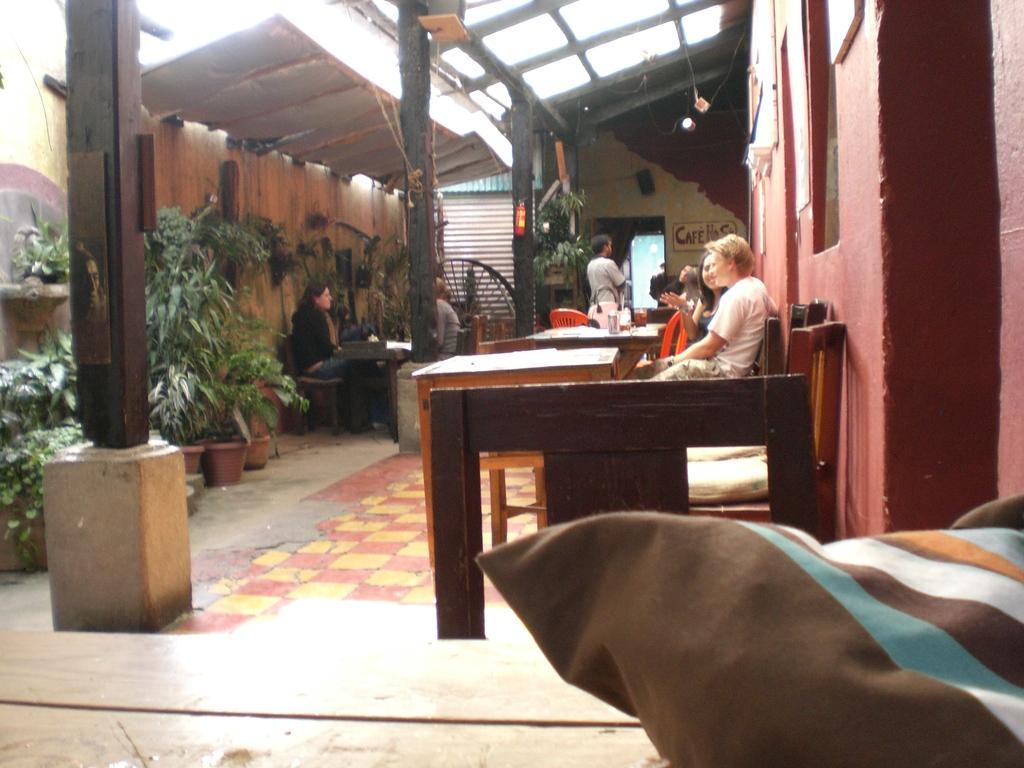Can you describe this image briefly? people are sitting on the chair. in front of them there are tables. at the right there is a red wall. at the left there are plants. 